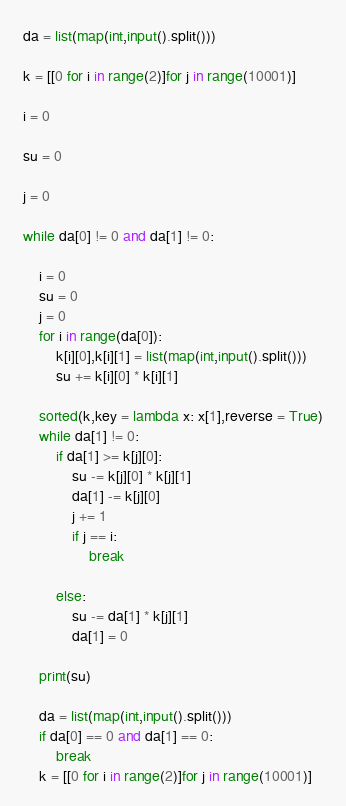Convert code to text. <code><loc_0><loc_0><loc_500><loc_500><_Python_>da = list(map(int,input().split()))

k = [[0 for i in range(2)]for j in range(10001)]

i = 0

su = 0

j = 0

while da[0] != 0 and da[1] != 0:

	i = 0
	su = 0
	j = 0
	for i in range(da[0]):
		k[i][0],k[i][1] = list(map(int,input().split()))
		su += k[i][0] * k[i][1]

	sorted(k,key = lambda x: x[1],reverse = True)
	while da[1] != 0:
		if da[1] >= k[j][0]:
			su -= k[j][0] * k[j][1]
			da[1] -= k[j][0]
			j += 1
			if j == i:
				break

		else:
			su -= da[1] * k[j][1]
			da[1] = 0

	print(su)

	da = list(map(int,input().split()))
	if da[0] == 0 and da[1] == 0:
		break
	k = [[0 for i in range(2)]for j in range(10001)]

</code> 